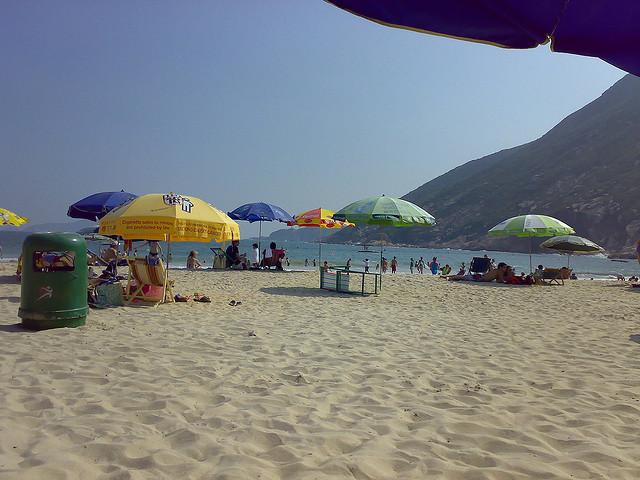Do these umbrellas belong to the beach?
Keep it brief. Yes. How many umbrellas are in the picture?
Answer briefly. 8. How many yellow umbrellas?
Short answer required. 3. How many yellow umbrellas are standing?
Short answer required. 3. What are the people doing?
Be succinct. Sunbathing. How  many different colors do you see on the umbrellas?
Write a very short answer. 3. Is there a litter bin close by?
Give a very brief answer. Yes. How many yellow umbrellas are there?
Be succinct. 3. What color is the barrel?
Write a very short answer. Green. How many people are sitting on beach chairs?
Write a very short answer. At least 4. What color is the sand?
Short answer required. Tan. 